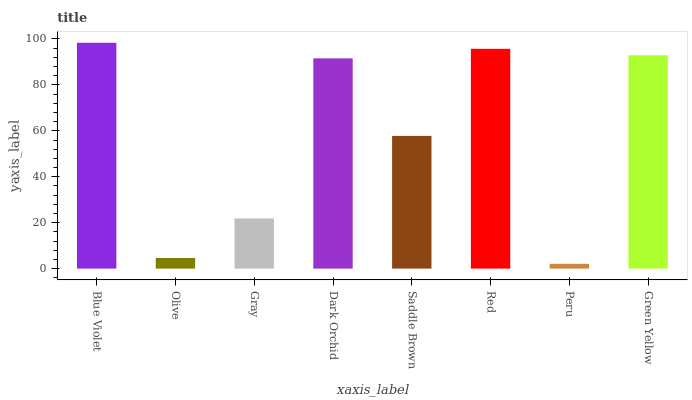Is Peru the minimum?
Answer yes or no. Yes. Is Blue Violet the maximum?
Answer yes or no. Yes. Is Olive the minimum?
Answer yes or no. No. Is Olive the maximum?
Answer yes or no. No. Is Blue Violet greater than Olive?
Answer yes or no. Yes. Is Olive less than Blue Violet?
Answer yes or no. Yes. Is Olive greater than Blue Violet?
Answer yes or no. No. Is Blue Violet less than Olive?
Answer yes or no. No. Is Dark Orchid the high median?
Answer yes or no. Yes. Is Saddle Brown the low median?
Answer yes or no. Yes. Is Green Yellow the high median?
Answer yes or no. No. Is Dark Orchid the low median?
Answer yes or no. No. 